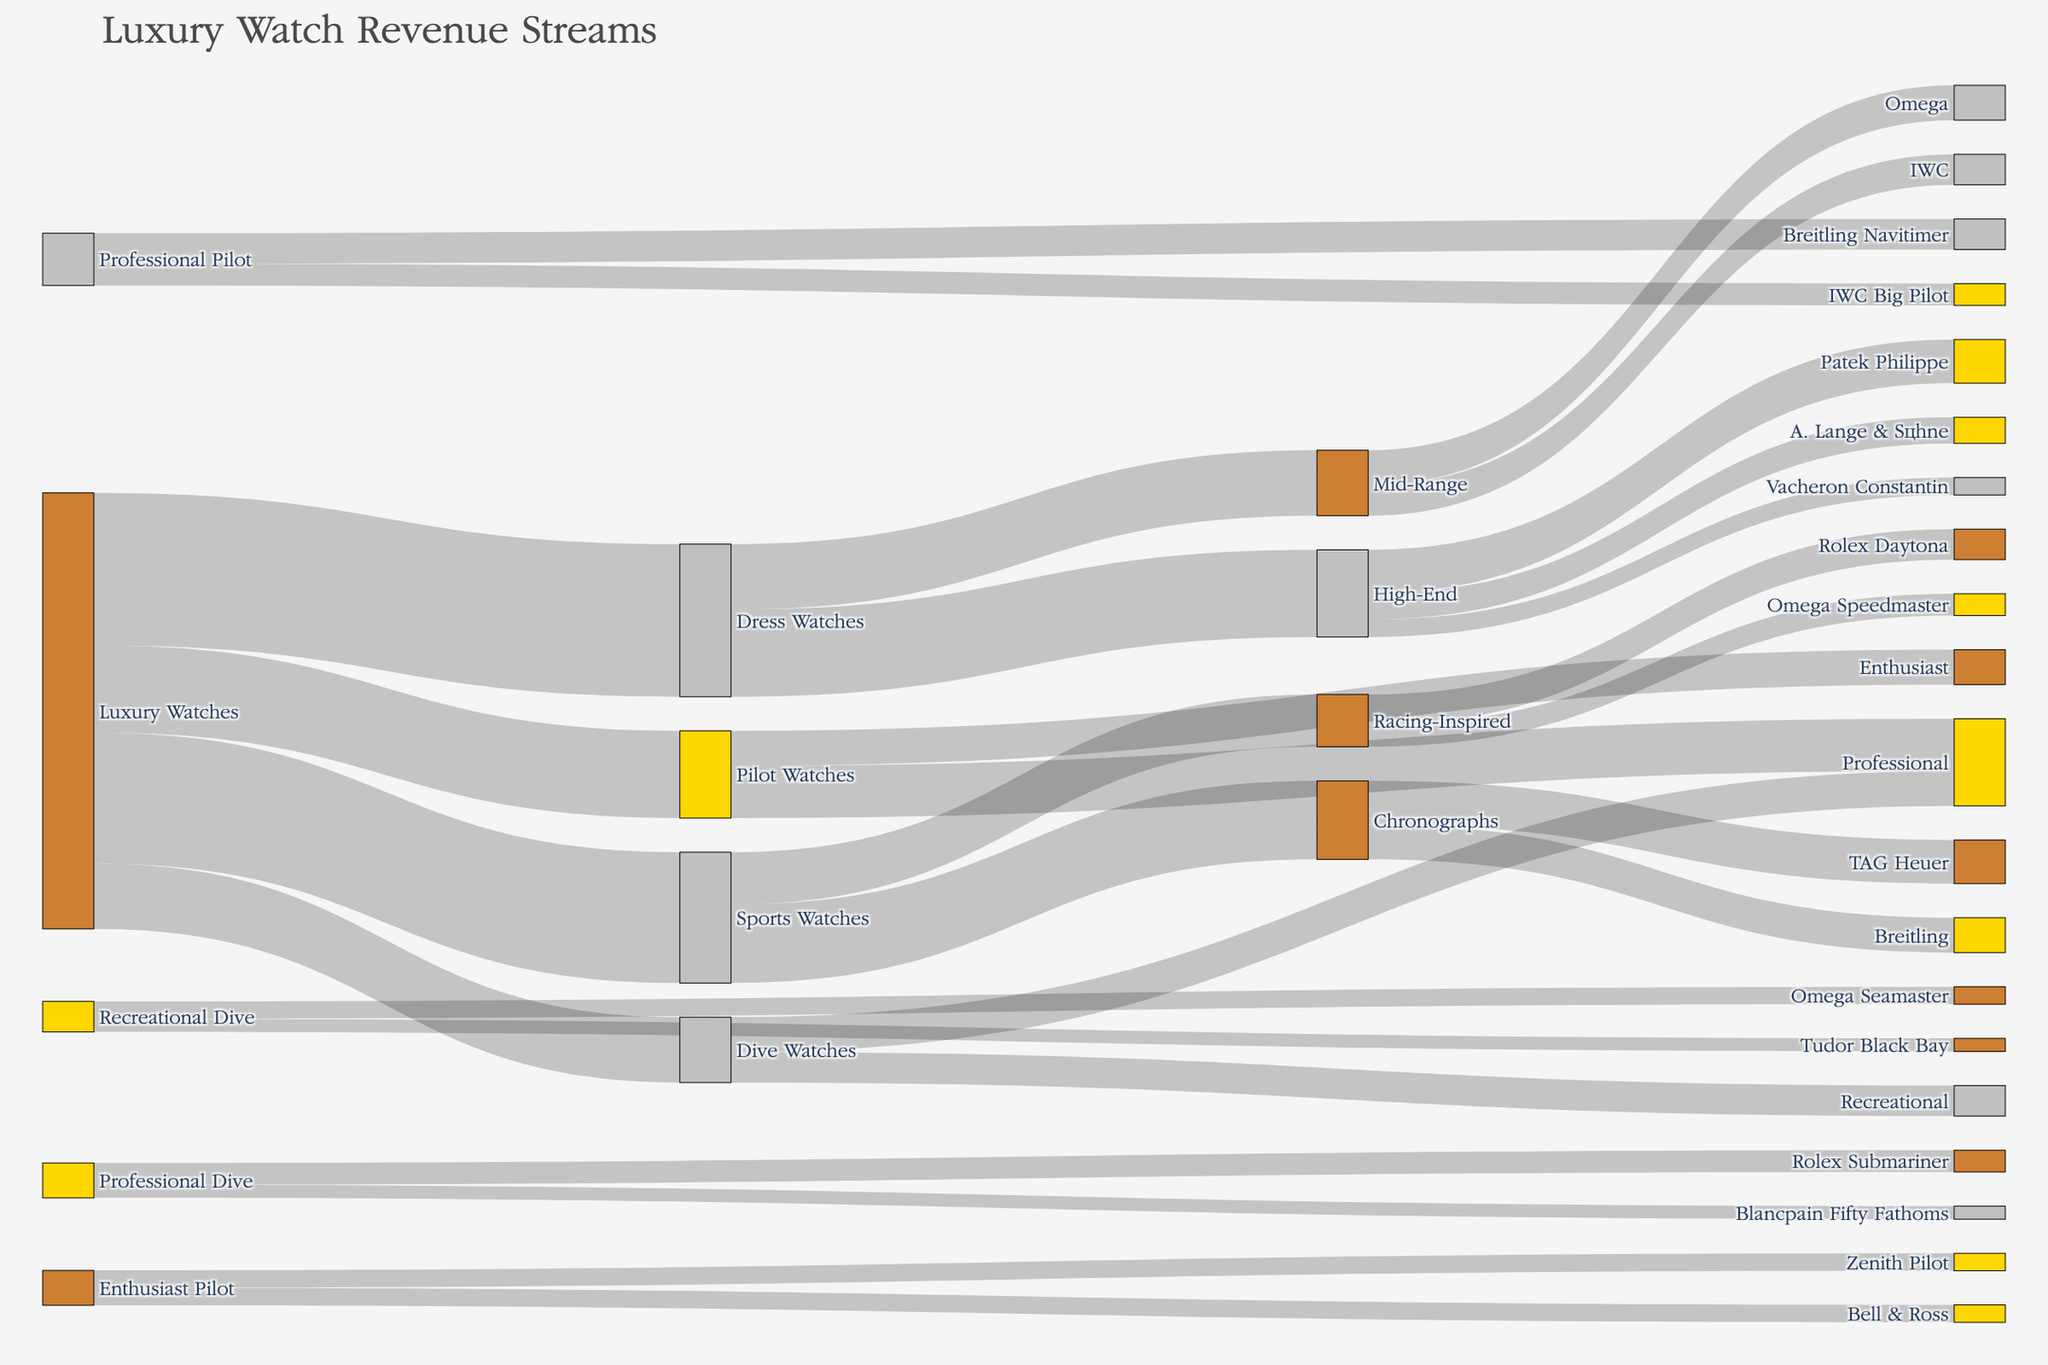Which type of luxury watch has the largest revenue stream? Looking at the widest link that starts from "Luxury Watches", we see that "Dress Watches" has a value of 35, which is the largest.
Answer: Dress Watches How much total revenue does the “Professional” segment contribute to? Locate all the links ending in “Professional.” Adding the values of “Professional” segments in Pilot Watches (12) and Dive Watches (8), we get 12 + 8.
Answer: 20 What is the revenue difference between “Sports Watches” and “Dive Watches”? Identify the values for each category: "Sports Watches" has 30 and "Dive Watches" has 15. The difference is 30 - 15.
Answer: 15 Which brand within the “High-End” segment has the least revenue? Observe the values associated with each brand within the “High-End” segment. “Vacheron Constantin” has the smallest value of 4.
Answer: Vacheron Constantin How does the revenue for “Omega” in the “Mid-Range” segment compare to the combined revenue of “Breitling” and “TAG Heuer” in the “Chronographs” segment? Omega’s value in Mid-Range is 8. The combined value of “Breitling” (8) and “TAG Heuer” (10) is 18. Comparing 8 and 18.
Answer: Omega has less revenue What is the combined revenue of all the watches branded by “IWC”? Locate “IWC” in both Mid-Range and Professional Pilot. Values are 7 (Mid-Range) + 5 (Professional Pilot).
Answer: 12 Which “Racing-Inspired” watch brand has higher revenue? Compare the values of brands under “Racing-Inspired”: “Rolex Daytona” (7) and “Omega Speedmaster” (5).
Answer: Rolex Daytona How much total revenue do “Chronographs” contribute within the “Sports Watches” category? Sum the values of “Chronographs”: TAG Heuer (10) + Breitling (8).
Answer: 18 If we combine the revenue from “Patek Philippe” and “Omega,” how does it compare to the revenue from “Breitling” alone in the “Chronographs” segment? Patek Philippe (10) + Omega (8) = 18. Compare it to Breitling (8).
Answer: Combined revenue is higher What is the total revenue generated by brands under the “Recreational Dive” category? Sum the values of “Omega Seamaster” (4) and “Tudor Black Bay” (3).
Answer: 7 